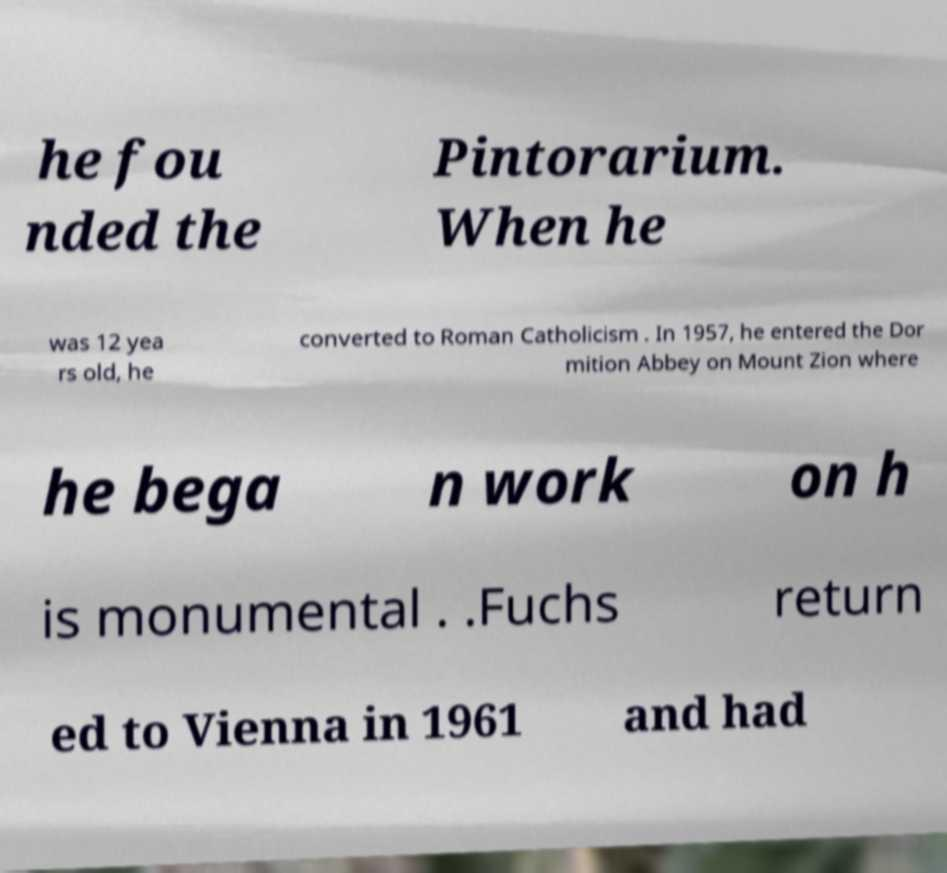Could you assist in decoding the text presented in this image and type it out clearly? he fou nded the Pintorarium. When he was 12 yea rs old, he converted to Roman Catholicism . In 1957, he entered the Dor mition Abbey on Mount Zion where he bega n work on h is monumental . .Fuchs return ed to Vienna in 1961 and had 